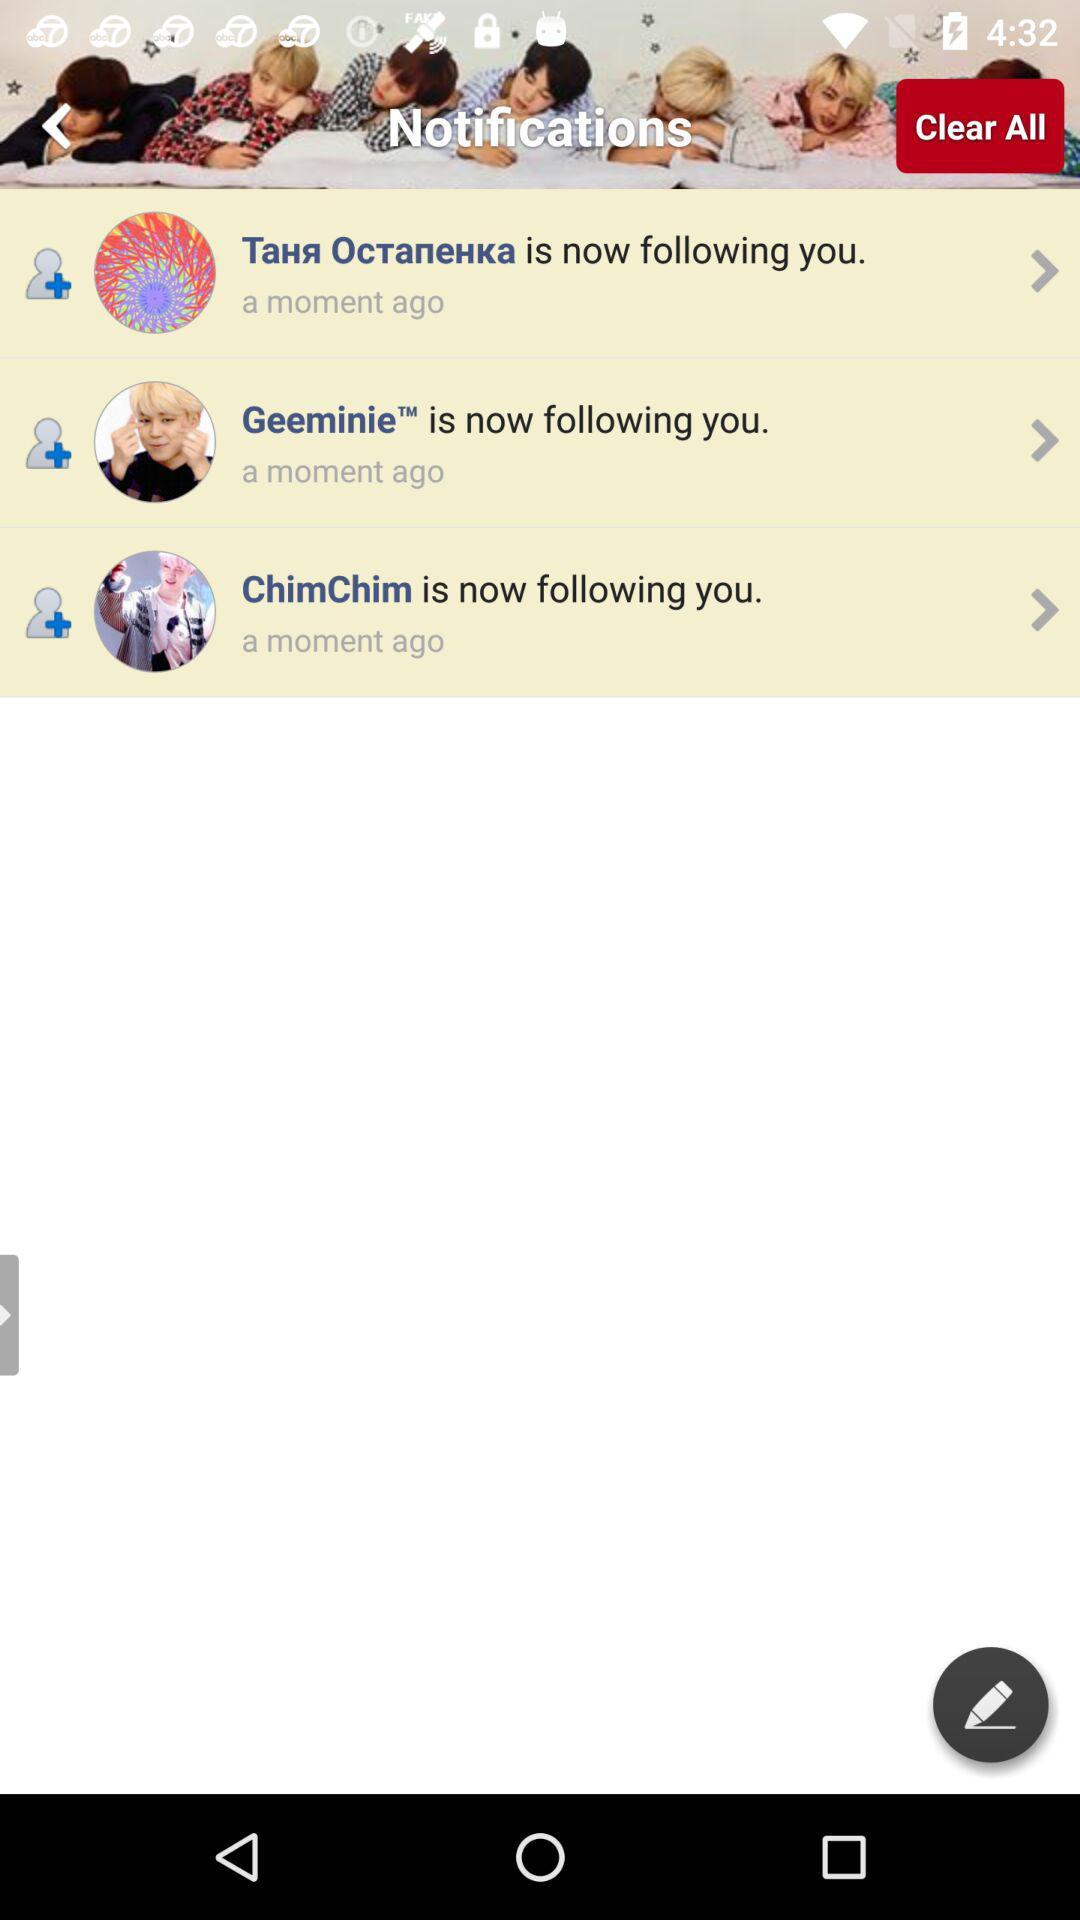How many people are following you?
Answer the question using a single word or phrase. 3 